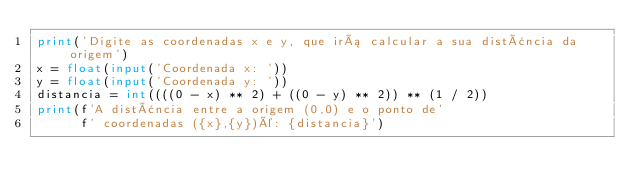<code> <loc_0><loc_0><loc_500><loc_500><_Python_>print('Digite as coordenadas x e y, que irá calcular a sua distância da origem')
x = float(input('Coordenada x: '))
y = float(input('Coordenada y: '))
distancia = int((((0 - x) ** 2) + ((0 - y) ** 2)) ** (1 / 2))
print(f'A distância entre a origem (0,0) e o ponto de'
      f' coordenadas ({x},{y})é: {distancia}')</code> 